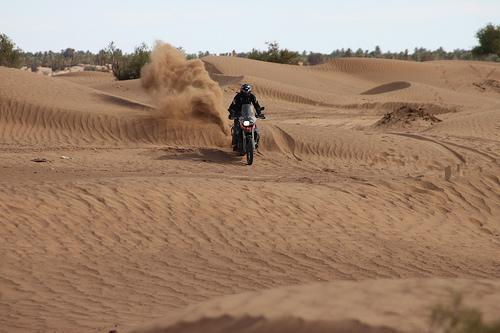Identify the action performed by the motorbike and its consequences. The motorbike is kicking up sand into the air as it rides on the beach, creating a plume of sand and dust behind it. List three objects that can be found on the sand. A dark spot, a whitish object, and a random object can be found on the sand. Describe the terrain and the setting in the image. The image shows a sandy beach with dunes, tracks, and a field of sand, with green trees in the background and a section of hazy blue sky. What part of the motorbike is illuminated and what color is it? The headlight of the motorcycle is on and it is bright. Mention any natural vegetation found in the image. There are plants growing in the sand, a large leaf-filled tree, and trees with lots of green leaves. What can be found in the left-top of the image with XY coordinates of (237, 73)? A helmet of the biker can be found in the left-top-corner of the image at (237, 73). Explain the disposition of the rider and the motorbike. The rider is wearing a black helmet and racing on a dirt bike track, while the motorbike has a bright headlamp, protective screen, and front headlight. What is happening with the sand behind the motorcycle? There is a plume of sand being kicked up behind the motorcycle as it rides on the beach. What type of safety gear is the rider wearing in the image? The rider is wearing a safety helmet on their head. 